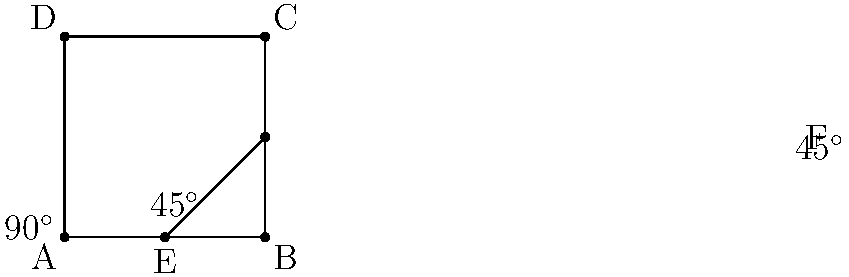In a dentist's office, the chair can be adjusted to various angles for patient comfort. The diagram shows a simplified representation of the chair's positioning system. Angle DAB is fixed at 90°. If angle EBF is 45°, what is the measure of angle AEF? Let's approach this step-by-step:

1) First, we need to recognize that angle DAB is a right angle (90°).

2) We're told that angle EBF is 45°.

3) In a right angle, when one angle is 45°, the other must also be 45° because:
   $$90^\circ = 45^\circ + 45^\circ$$

4) Therefore, angle AEB is also 45°.

5) Now, we need to consider the relationship between angles AEB and AEF:
   - These angles form a straight line at point E.
   - Angles that form a straight line are supplementary, meaning they add up to 180°.

6) We can set up an equation:
   $$AEB + AEF = 180^\circ$$

7) We know AEB is 45°, so we can substitute:
   $$45^\circ + AEF = 180^\circ$$

8) To solve for AEF, we subtract 45° from both sides:
   $$AEF = 180^\circ - 45^\circ = 135^\circ$$

Therefore, the measure of angle AEF is 135°.
Answer: $135^\circ$ 